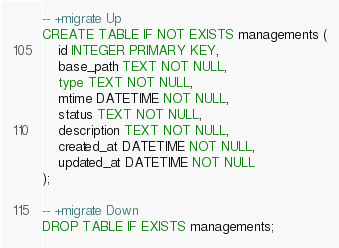Convert code to text. <code><loc_0><loc_0><loc_500><loc_500><_SQL_>-- +migrate Up
CREATE TABLE IF NOT EXISTS managements (
    id INTEGER PRIMARY KEY,
    base_path TEXT NOT NULL,
    type TEXT NOT NULL,
    mtime DATETIME NOT NULL,
    status TEXT NOT NULL,
    description TEXT NOT NULL,
    created_at DATETIME NOT NULL,
    updated_at DATETIME NOT NULL
);

-- +migrate Down
DROP TABLE IF EXISTS managements;
</code> 